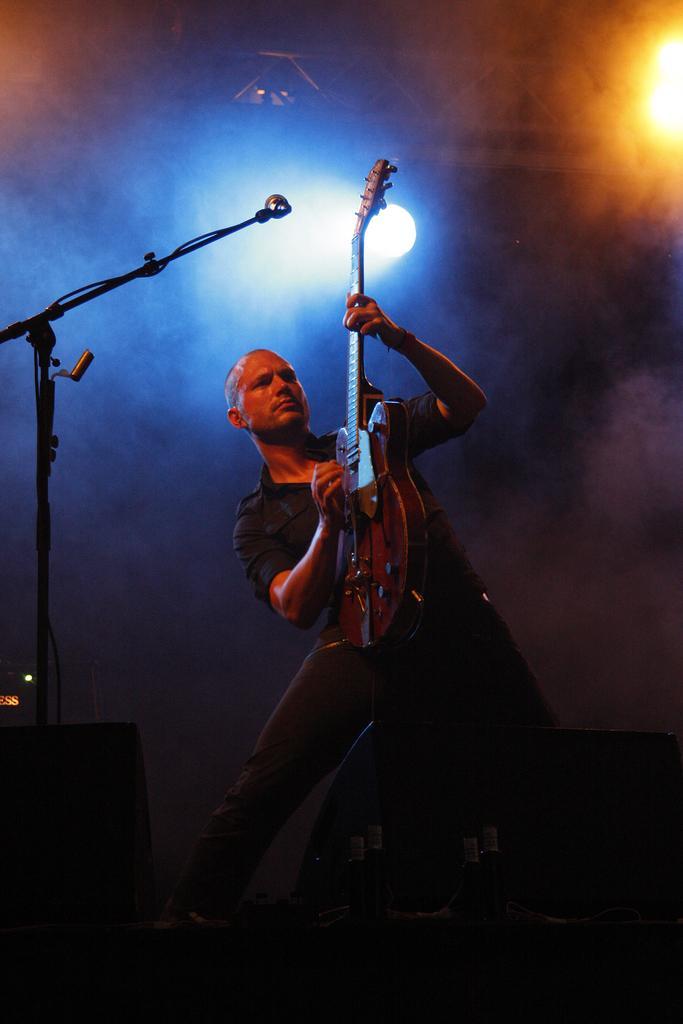Can you describe this image briefly? A man is playing a guitar. In the left corner there is a mic stand. In the background there are some lights. In the front there are some speakers kept on the stage. 